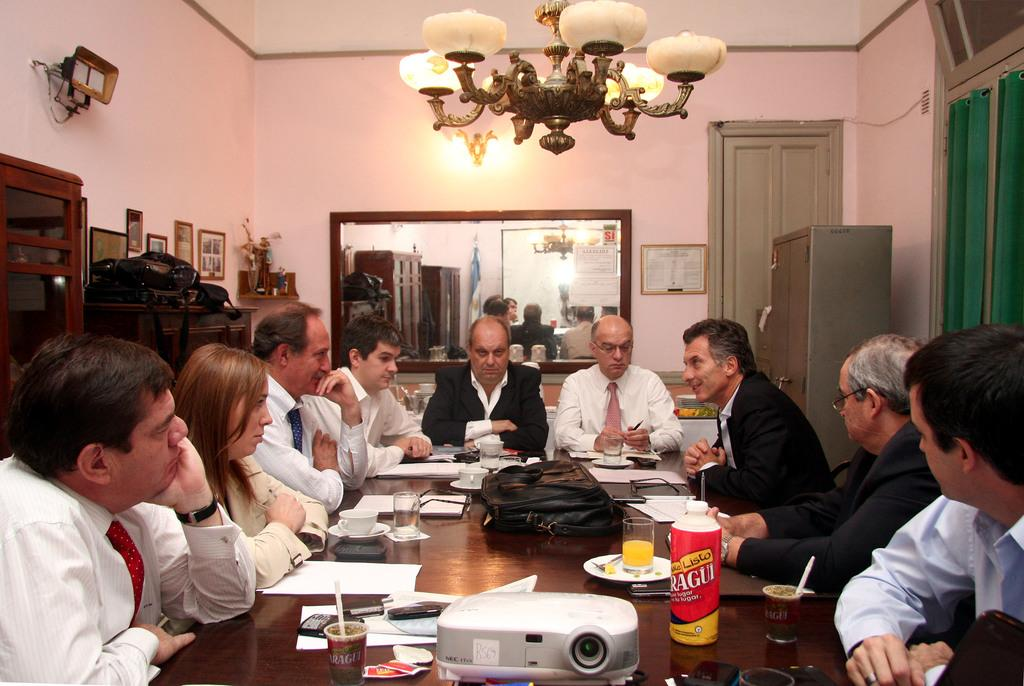What are the people in the image doing? The people in the image are sitting on chairs. What is present on the table in the image? There is a table in the image, and on it, there is a projector and a bottle. What might the people be using the projector for? The people might be using the projector for a presentation or to display visuals. What type of engine is visible in the image? There is no engine present in the image. What selection of items can be seen on the table in the image? The table in the image contains a projector and a bottle, but there is no selection of items. 